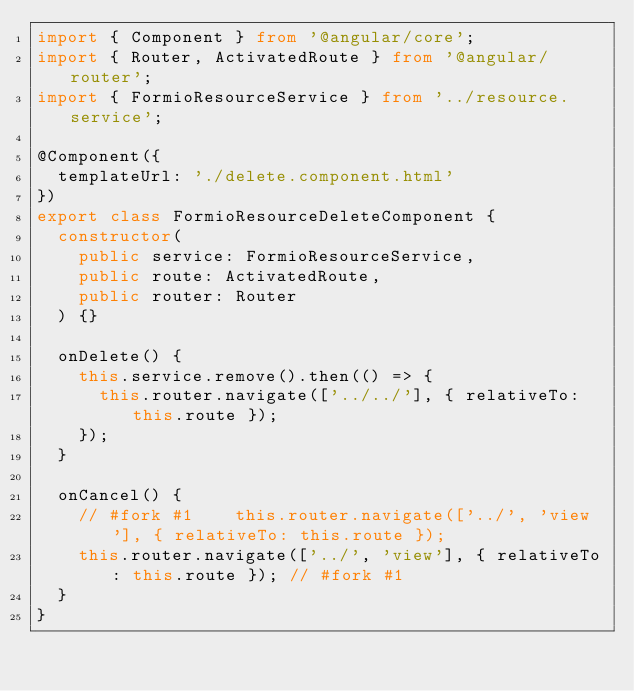<code> <loc_0><loc_0><loc_500><loc_500><_TypeScript_>import { Component } from '@angular/core';
import { Router, ActivatedRoute } from '@angular/router';
import { FormioResourceService } from '../resource.service';

@Component({
  templateUrl: './delete.component.html'
})
export class FormioResourceDeleteComponent {
  constructor(
    public service: FormioResourceService,
    public route: ActivatedRoute,
    public router: Router
  ) {}

  onDelete() {
    this.service.remove().then(() => {
      this.router.navigate(['../../'], { relativeTo: this.route });
    });
  }

  onCancel() {
    // #fork #1    this.router.navigate(['../', 'view'], { relativeTo: this.route });
    this.router.navigate(['../', 'view'], { relativeTo: this.route }); // #fork #1
  }
}
</code> 